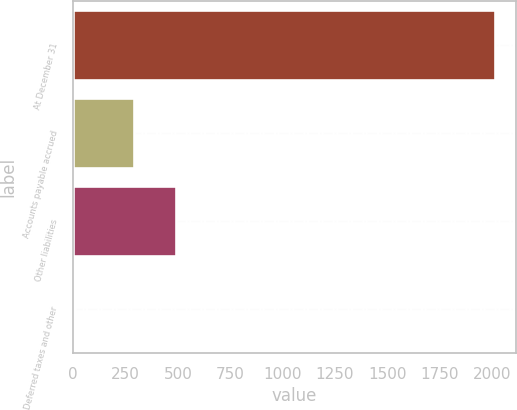Convert chart. <chart><loc_0><loc_0><loc_500><loc_500><bar_chart><fcel>At December 31<fcel>Accounts payable accrued<fcel>Other liabilities<fcel>Deferred taxes and other<nl><fcel>2013<fcel>291.7<fcel>491.87<fcel>11.3<nl></chart> 